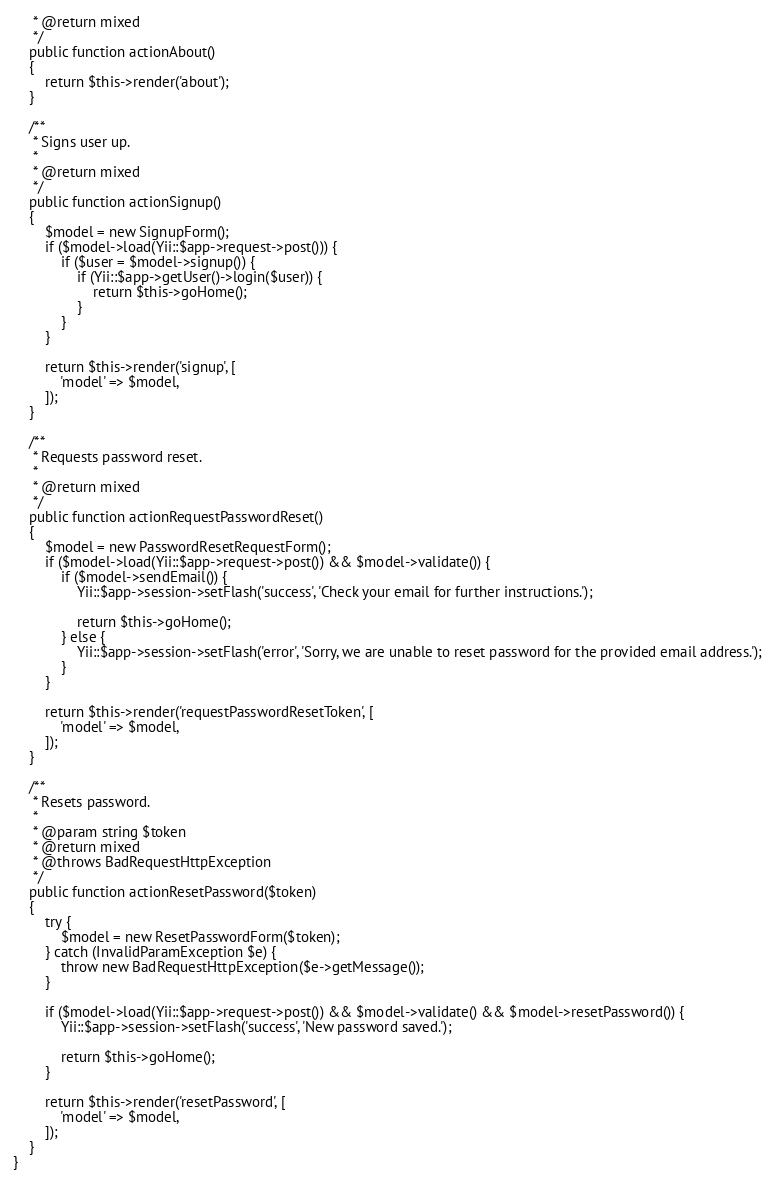Convert code to text. <code><loc_0><loc_0><loc_500><loc_500><_PHP_>     * @return mixed
     */
    public function actionAbout()
    {
        return $this->render('about');
    }

    /**
     * Signs user up.
     *
     * @return mixed
     */
    public function actionSignup()
    {
        $model = new SignupForm();
        if ($model->load(Yii::$app->request->post())) {
            if ($user = $model->signup()) {
                if (Yii::$app->getUser()->login($user)) {
                    return $this->goHome();
                }
            }
        }

        return $this->render('signup', [
            'model' => $model,
        ]);
    }

    /**
     * Requests password reset.
     *
     * @return mixed
     */
    public function actionRequestPasswordReset()
    {
        $model = new PasswordResetRequestForm();
        if ($model->load(Yii::$app->request->post()) && $model->validate()) {
            if ($model->sendEmail()) {
                Yii::$app->session->setFlash('success', 'Check your email for further instructions.');

                return $this->goHome();
            } else {
                Yii::$app->session->setFlash('error', 'Sorry, we are unable to reset password for the provided email address.');
            }
        }

        return $this->render('requestPasswordResetToken', [
            'model' => $model,
        ]);
    }

    /**
     * Resets password.
     *
     * @param string $token
     * @return mixed
     * @throws BadRequestHttpException
     */
    public function actionResetPassword($token)
    {
        try {
            $model = new ResetPasswordForm($token);
        } catch (InvalidParamException $e) {
            throw new BadRequestHttpException($e->getMessage());
        }

        if ($model->load(Yii::$app->request->post()) && $model->validate() && $model->resetPassword()) {
            Yii::$app->session->setFlash('success', 'New password saved.');

            return $this->goHome();
        }

        return $this->render('resetPassword', [
            'model' => $model,
        ]);
    }
}
</code> 